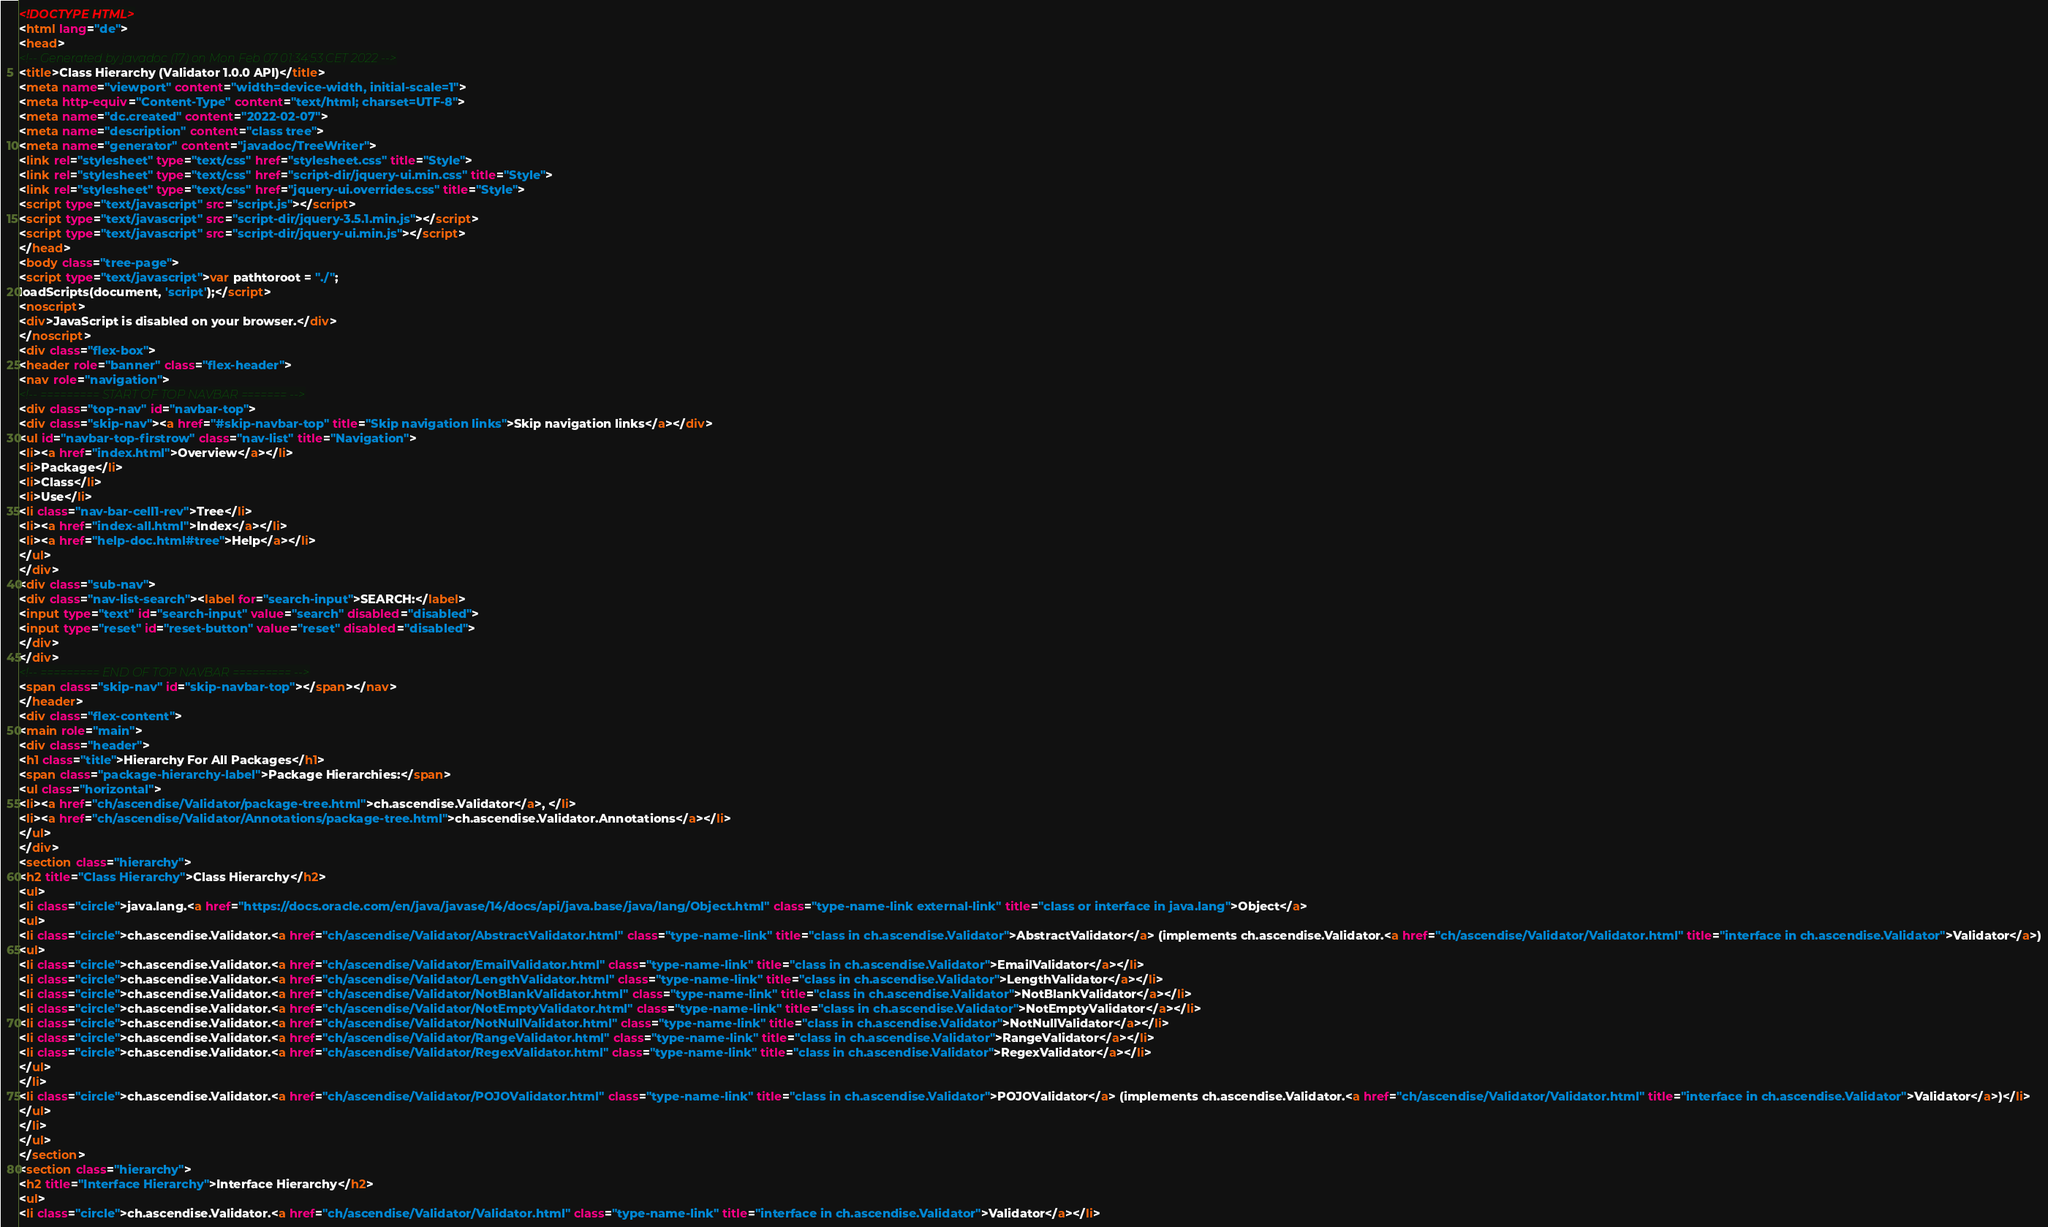Convert code to text. <code><loc_0><loc_0><loc_500><loc_500><_HTML_><!DOCTYPE HTML>
<html lang="de">
<head>
<!-- Generated by javadoc (17) on Mon Feb 07 01:34:53 CET 2022 -->
<title>Class Hierarchy (Validator 1.0.0 API)</title>
<meta name="viewport" content="width=device-width, initial-scale=1">
<meta http-equiv="Content-Type" content="text/html; charset=UTF-8">
<meta name="dc.created" content="2022-02-07">
<meta name="description" content="class tree">
<meta name="generator" content="javadoc/TreeWriter">
<link rel="stylesheet" type="text/css" href="stylesheet.css" title="Style">
<link rel="stylesheet" type="text/css" href="script-dir/jquery-ui.min.css" title="Style">
<link rel="stylesheet" type="text/css" href="jquery-ui.overrides.css" title="Style">
<script type="text/javascript" src="script.js"></script>
<script type="text/javascript" src="script-dir/jquery-3.5.1.min.js"></script>
<script type="text/javascript" src="script-dir/jquery-ui.min.js"></script>
</head>
<body class="tree-page">
<script type="text/javascript">var pathtoroot = "./";
loadScripts(document, 'script');</script>
<noscript>
<div>JavaScript is disabled on your browser.</div>
</noscript>
<div class="flex-box">
<header role="banner" class="flex-header">
<nav role="navigation">
<!-- ========= START OF TOP NAVBAR ======= -->
<div class="top-nav" id="navbar-top">
<div class="skip-nav"><a href="#skip-navbar-top" title="Skip navigation links">Skip navigation links</a></div>
<ul id="navbar-top-firstrow" class="nav-list" title="Navigation">
<li><a href="index.html">Overview</a></li>
<li>Package</li>
<li>Class</li>
<li>Use</li>
<li class="nav-bar-cell1-rev">Tree</li>
<li><a href="index-all.html">Index</a></li>
<li><a href="help-doc.html#tree">Help</a></li>
</ul>
</div>
<div class="sub-nav">
<div class="nav-list-search"><label for="search-input">SEARCH:</label>
<input type="text" id="search-input" value="search" disabled="disabled">
<input type="reset" id="reset-button" value="reset" disabled="disabled">
</div>
</div>
<!-- ========= END OF TOP NAVBAR ========= -->
<span class="skip-nav" id="skip-navbar-top"></span></nav>
</header>
<div class="flex-content">
<main role="main">
<div class="header">
<h1 class="title">Hierarchy For All Packages</h1>
<span class="package-hierarchy-label">Package Hierarchies:</span>
<ul class="horizontal">
<li><a href="ch/ascendise/Validator/package-tree.html">ch.ascendise.Validator</a>, </li>
<li><a href="ch/ascendise/Validator/Annotations/package-tree.html">ch.ascendise.Validator.Annotations</a></li>
</ul>
</div>
<section class="hierarchy">
<h2 title="Class Hierarchy">Class Hierarchy</h2>
<ul>
<li class="circle">java.lang.<a href="https://docs.oracle.com/en/java/javase/14/docs/api/java.base/java/lang/Object.html" class="type-name-link external-link" title="class or interface in java.lang">Object</a>
<ul>
<li class="circle">ch.ascendise.Validator.<a href="ch/ascendise/Validator/AbstractValidator.html" class="type-name-link" title="class in ch.ascendise.Validator">AbstractValidator</a> (implements ch.ascendise.Validator.<a href="ch/ascendise/Validator/Validator.html" title="interface in ch.ascendise.Validator">Validator</a>)
<ul>
<li class="circle">ch.ascendise.Validator.<a href="ch/ascendise/Validator/EmailValidator.html" class="type-name-link" title="class in ch.ascendise.Validator">EmailValidator</a></li>
<li class="circle">ch.ascendise.Validator.<a href="ch/ascendise/Validator/LengthValidator.html" class="type-name-link" title="class in ch.ascendise.Validator">LengthValidator</a></li>
<li class="circle">ch.ascendise.Validator.<a href="ch/ascendise/Validator/NotBlankValidator.html" class="type-name-link" title="class in ch.ascendise.Validator">NotBlankValidator</a></li>
<li class="circle">ch.ascendise.Validator.<a href="ch/ascendise/Validator/NotEmptyValidator.html" class="type-name-link" title="class in ch.ascendise.Validator">NotEmptyValidator</a></li>
<li class="circle">ch.ascendise.Validator.<a href="ch/ascendise/Validator/NotNullValidator.html" class="type-name-link" title="class in ch.ascendise.Validator">NotNullValidator</a></li>
<li class="circle">ch.ascendise.Validator.<a href="ch/ascendise/Validator/RangeValidator.html" class="type-name-link" title="class in ch.ascendise.Validator">RangeValidator</a></li>
<li class="circle">ch.ascendise.Validator.<a href="ch/ascendise/Validator/RegexValidator.html" class="type-name-link" title="class in ch.ascendise.Validator">RegexValidator</a></li>
</ul>
</li>
<li class="circle">ch.ascendise.Validator.<a href="ch/ascendise/Validator/POJOValidator.html" class="type-name-link" title="class in ch.ascendise.Validator">POJOValidator</a> (implements ch.ascendise.Validator.<a href="ch/ascendise/Validator/Validator.html" title="interface in ch.ascendise.Validator">Validator</a>)</li>
</ul>
</li>
</ul>
</section>
<section class="hierarchy">
<h2 title="Interface Hierarchy">Interface Hierarchy</h2>
<ul>
<li class="circle">ch.ascendise.Validator.<a href="ch/ascendise/Validator/Validator.html" class="type-name-link" title="interface in ch.ascendise.Validator">Validator</a></li></code> 